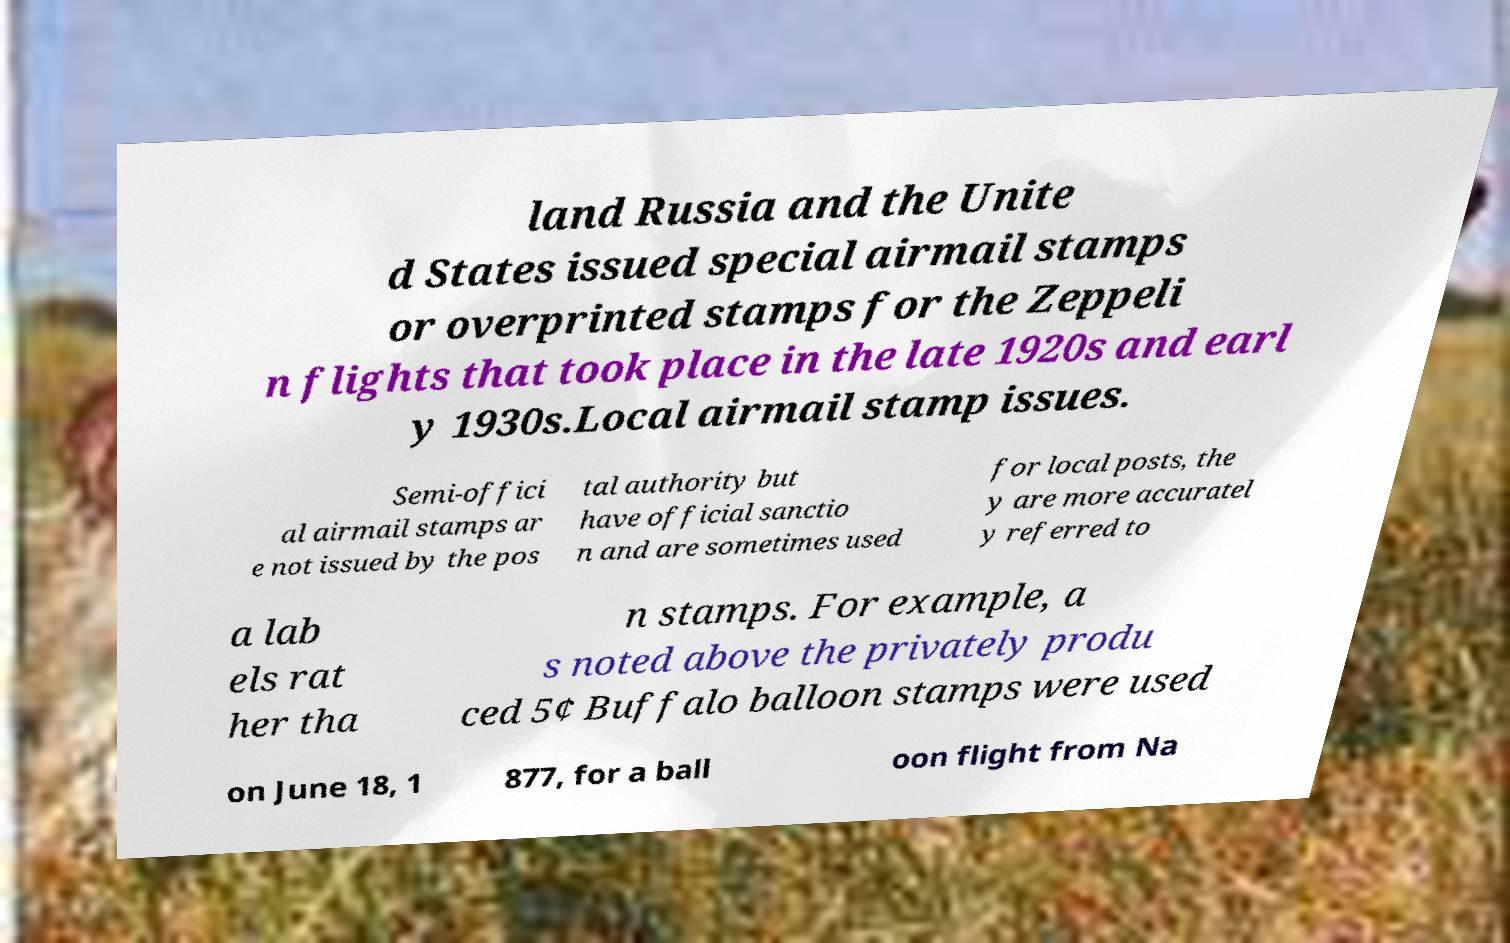Could you extract and type out the text from this image? land Russia and the Unite d States issued special airmail stamps or overprinted stamps for the Zeppeli n flights that took place in the late 1920s and earl y 1930s.Local airmail stamp issues. Semi-offici al airmail stamps ar e not issued by the pos tal authority but have official sanctio n and are sometimes used for local posts, the y are more accuratel y referred to a lab els rat her tha n stamps. For example, a s noted above the privately produ ced 5¢ Buffalo balloon stamps were used on June 18, 1 877, for a ball oon flight from Na 